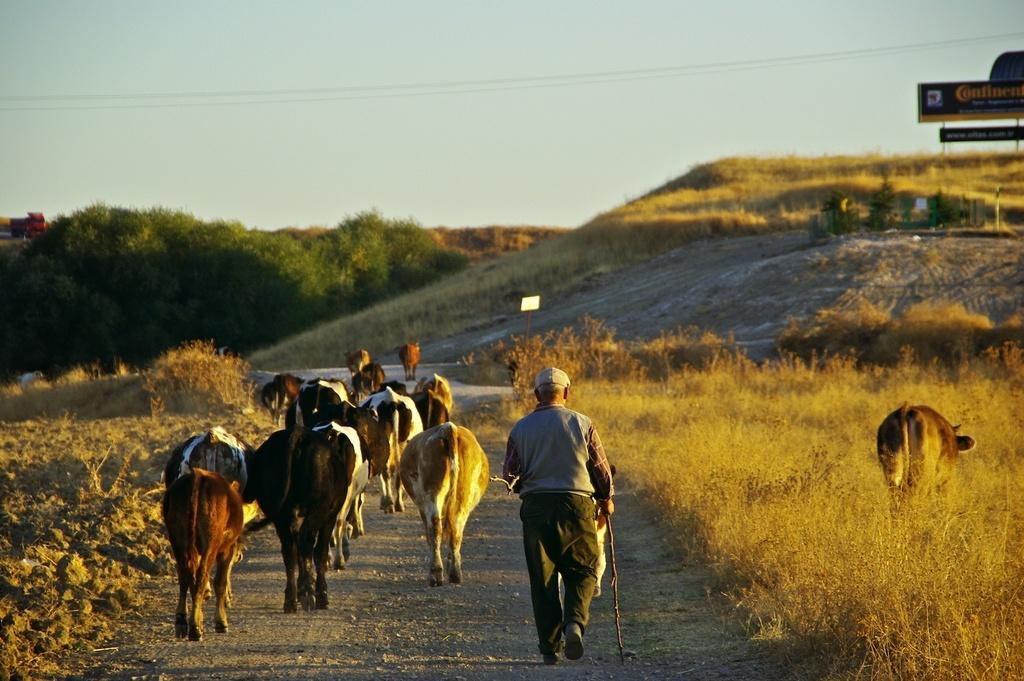What type of animals can be seen in the image? There are cows in the image. What is the person in the image doing? There is a person walking on the ground in the image. What type of vegetation is present in the image? Trees and grass are visible in the image. What might be used for identification purposes in the image? There are name boards in the image. What can be seen in the background of the image? The sky is visible in the background of the image. What type of dress is the queen wearing in the image? There is no queen present in the image, so it is not possible to answer that question. 